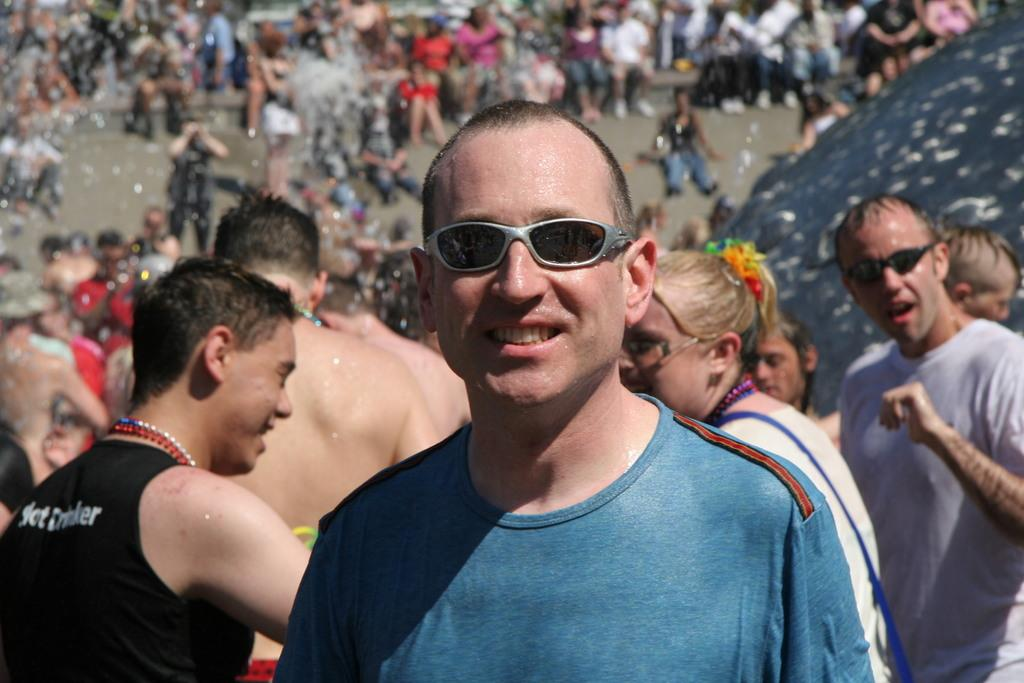Who is present in the image? There is a man in the image. What is the man wearing? The man is wearing goggles. What is the man's facial expression? The man is smiling. What can be seen in the background of the image? There is water and a group of people visible in the background of the image. What are the people in the group doing? Some people in the group are standing, and some people in the group are sitting. What type of toys can be seen being pulled by the man in the image? There are no toys present in the image, and the man is not pulling anything. What is the purpose of the protest in the image? There is no protest depicted in the image; it features a man wearing goggles, smiling, and a group of people in the background. 